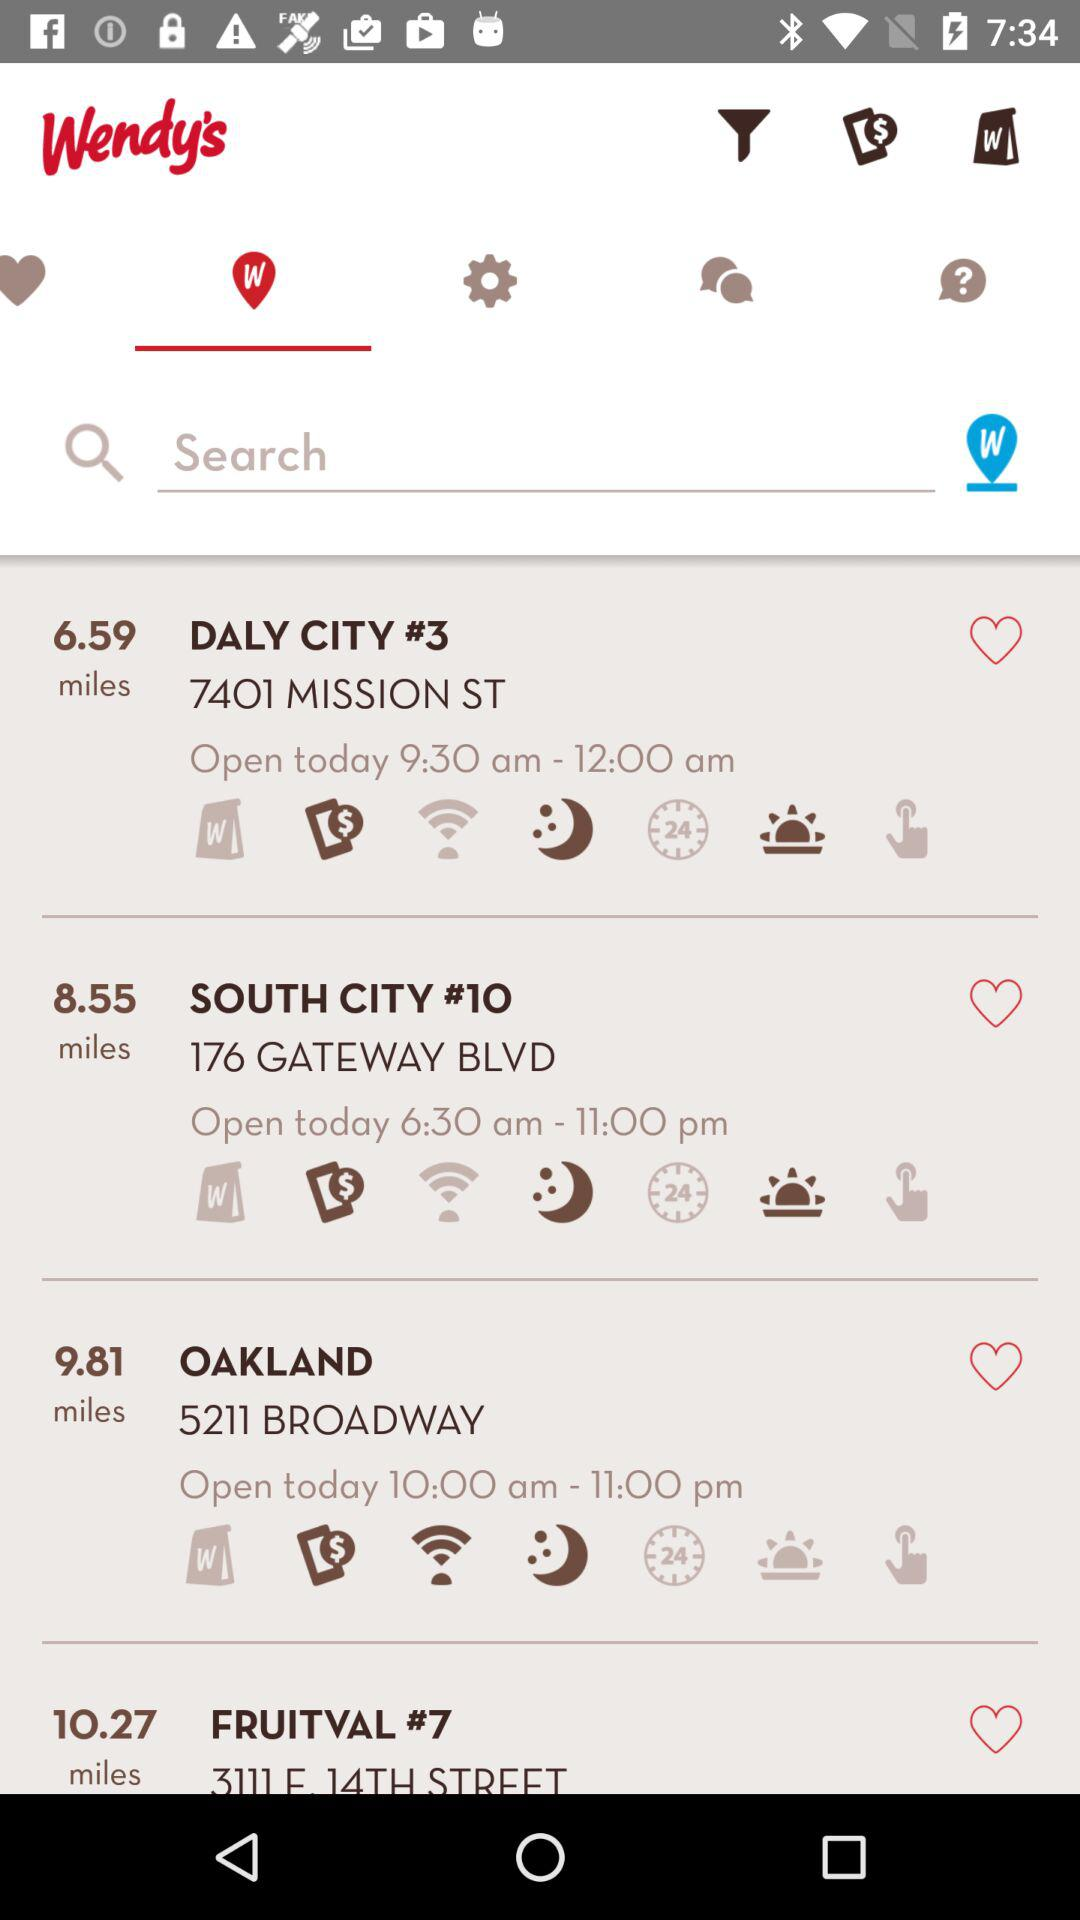What is the application name? The application name is " Wendy’s". 